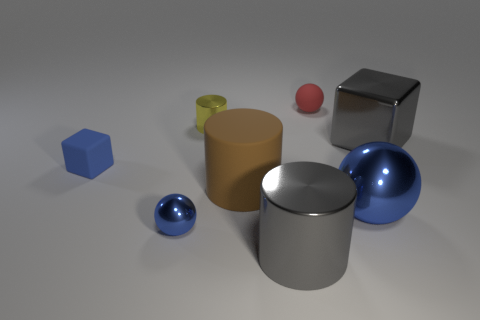The yellow object that is the same size as the red sphere is what shape? cylinder 